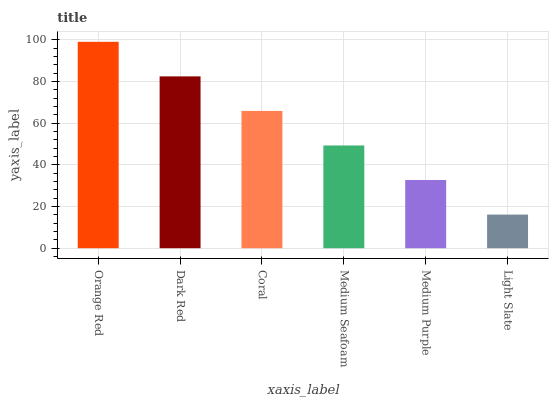Is Light Slate the minimum?
Answer yes or no. Yes. Is Orange Red the maximum?
Answer yes or no. Yes. Is Dark Red the minimum?
Answer yes or no. No. Is Dark Red the maximum?
Answer yes or no. No. Is Orange Red greater than Dark Red?
Answer yes or no. Yes. Is Dark Red less than Orange Red?
Answer yes or no. Yes. Is Dark Red greater than Orange Red?
Answer yes or no. No. Is Orange Red less than Dark Red?
Answer yes or no. No. Is Coral the high median?
Answer yes or no. Yes. Is Medium Seafoam the low median?
Answer yes or no. Yes. Is Light Slate the high median?
Answer yes or no. No. Is Light Slate the low median?
Answer yes or no. No. 